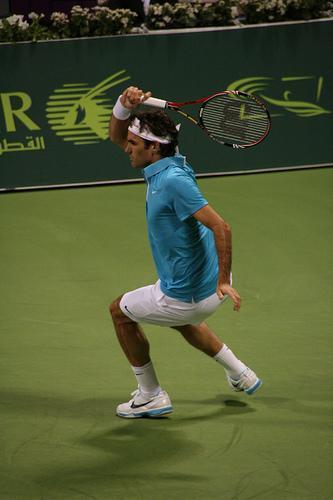How many bands is the player wearing?
Give a very brief answer. 2. How many English letters are to the left of the caricature of the gazelle?
Give a very brief answer. 1. 